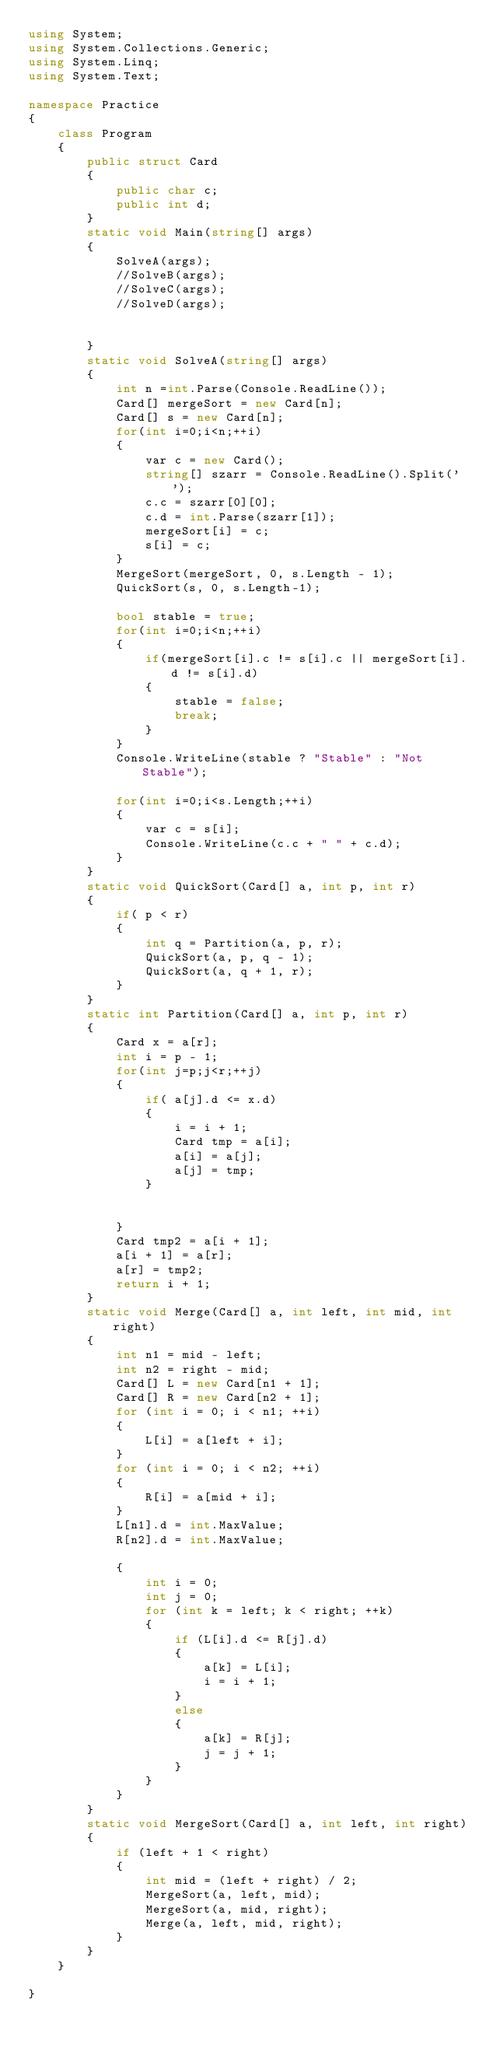Convert code to text. <code><loc_0><loc_0><loc_500><loc_500><_C#_>using System;
using System.Collections.Generic;
using System.Linq;
using System.Text;

namespace Practice
{
    class Program
    {
        public struct Card
        {
            public char c;
            public int d;
        }
        static void Main(string[] args)
        {
            SolveA(args);
            //SolveB(args);
            //SolveC(args);
            //SolveD(args);


        }
        static void SolveA(string[] args)
        {
            int n =int.Parse(Console.ReadLine());
            Card[] mergeSort = new Card[n];
            Card[] s = new Card[n];
            for(int i=0;i<n;++i)
            {
                var c = new Card();
                string[] szarr = Console.ReadLine().Split(' ');
                c.c = szarr[0][0];
                c.d = int.Parse(szarr[1]);
                mergeSort[i] = c;
                s[i] = c;
            }
            MergeSort(mergeSort, 0, s.Length - 1);
            QuickSort(s, 0, s.Length-1);

            bool stable = true;
            for(int i=0;i<n;++i)
            {
                if(mergeSort[i].c != s[i].c || mergeSort[i].d != s[i].d)
                {
                    stable = false;
                    break;
                }
            }
            Console.WriteLine(stable ? "Stable" : "Not Stable");

            for(int i=0;i<s.Length;++i)
            {
                var c = s[i];
                Console.WriteLine(c.c + " " + c.d);
            }
        }
        static void QuickSort(Card[] a, int p, int r)
        {
            if( p < r)
            {
                int q = Partition(a, p, r);
                QuickSort(a, p, q - 1);
                QuickSort(a, q + 1, r);
            }
        }
        static int Partition(Card[] a, int p, int r)
        {
            Card x = a[r];
            int i = p - 1;
            for(int j=p;j<r;++j)
            {
                if( a[j].d <= x.d)
                {
                    i = i + 1;
                    Card tmp = a[i];
                    a[i] = a[j];
                    a[j] = tmp;
                }


            }
            Card tmp2 = a[i + 1];
            a[i + 1] = a[r];
            a[r] = tmp2;
            return i + 1;
        }
        static void Merge(Card[] a, int left, int mid, int right)
        {
            int n1 = mid - left;
            int n2 = right - mid;
            Card[] L = new Card[n1 + 1];
            Card[] R = new Card[n2 + 1];
            for (int i = 0; i < n1; ++i)
            {
                L[i] = a[left + i];
            }
            for (int i = 0; i < n2; ++i)
            {
                R[i] = a[mid + i];
            }
            L[n1].d = int.MaxValue;
            R[n2].d = int.MaxValue;

            {
                int i = 0;
                int j = 0;
                for (int k = left; k < right; ++k)
                {
                    if (L[i].d <= R[j].d)
                    {
                        a[k] = L[i];
                        i = i + 1;
                    }
                    else
                    {
                        a[k] = R[j];
                        j = j + 1;
                    }
                }
            }
        }
        static void MergeSort(Card[] a, int left, int right)
        {
            if (left + 1 < right)
            {
                int mid = (left + right) / 2;
                MergeSort(a, left, mid);
                MergeSort(a, mid, right);
                Merge(a, left, mid, right);
            }
        }
    }

}

</code> 